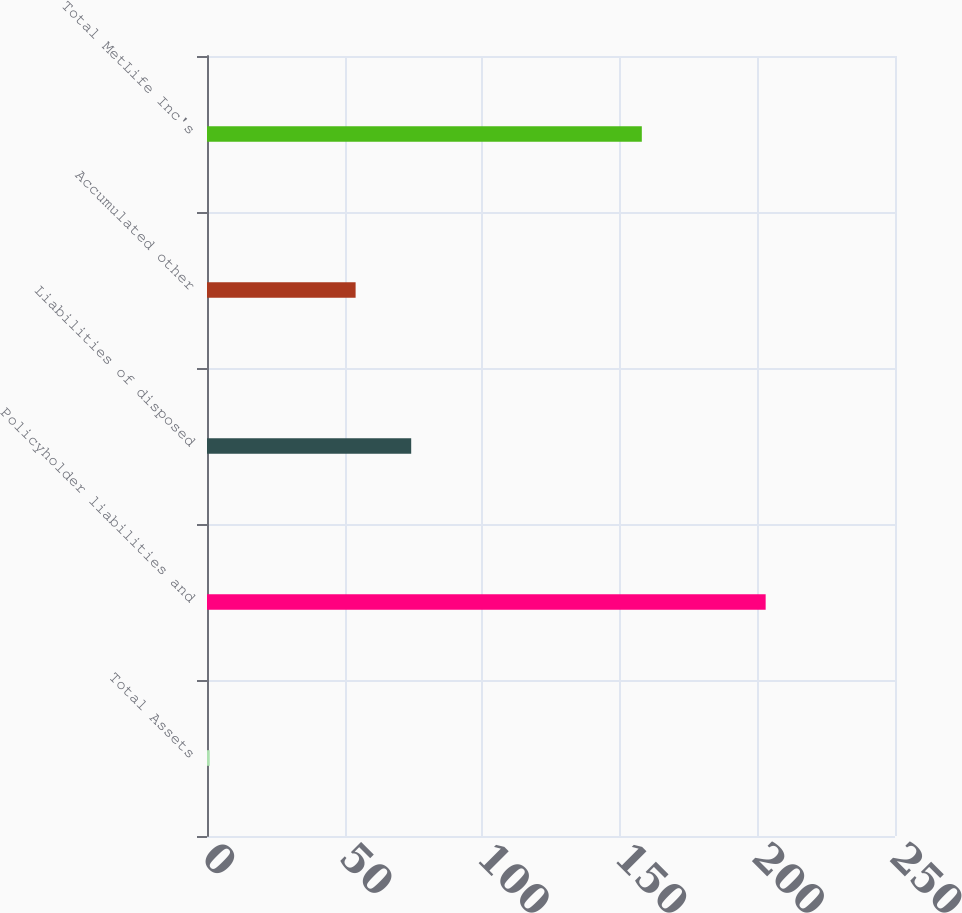<chart> <loc_0><loc_0><loc_500><loc_500><bar_chart><fcel>Total Assets<fcel>Policyholder liabilities and<fcel>Liabilities of disposed<fcel>Accumulated other<fcel>Total MetLife Inc's<nl><fcel>1<fcel>203<fcel>74.2<fcel>54<fcel>158<nl></chart> 